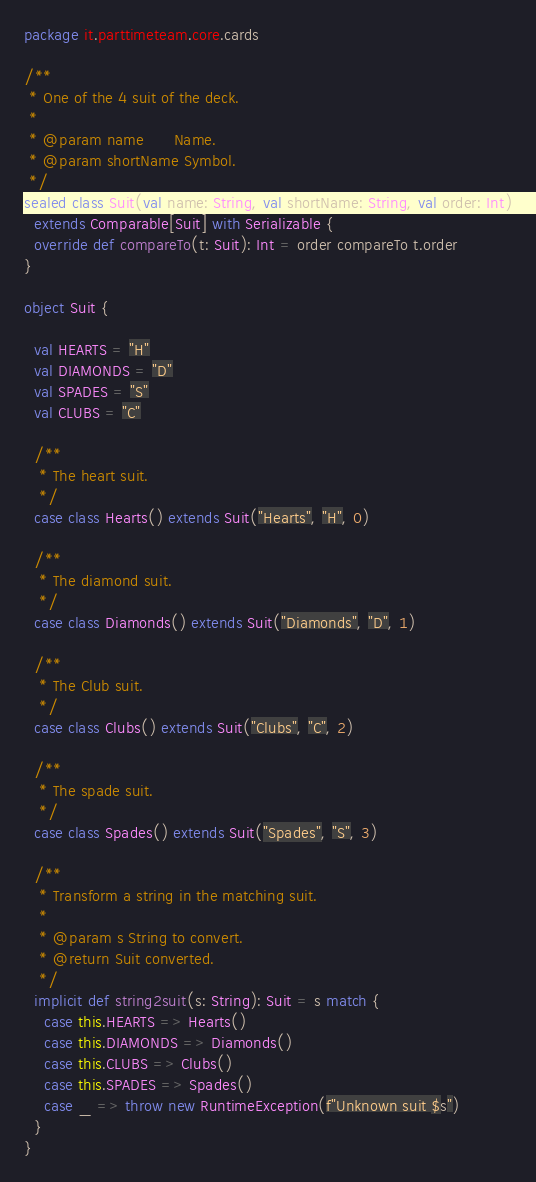<code> <loc_0><loc_0><loc_500><loc_500><_Scala_>package it.parttimeteam.core.cards

/**
 * One of the 4 suit of the deck.
 *
 * @param name      Name.
 * @param shortName Symbol.
 */
sealed class Suit(val name: String, val shortName: String, val order: Int)
  extends Comparable[Suit] with Serializable {
  override def compareTo(t: Suit): Int = order compareTo t.order
}

object Suit {

  val HEARTS = "H"
  val DIAMONDS = "D"
  val SPADES = "S"
  val CLUBS = "C"

  /**
   * The heart suit.
   */
  case class Hearts() extends Suit("Hearts", "H", 0)

  /**
   * The diamond suit.
   */
  case class Diamonds() extends Suit("Diamonds", "D", 1)

  /**
   * The Club suit.
   */
  case class Clubs() extends Suit("Clubs", "C", 2)

  /**
   * The spade suit.
   */
  case class Spades() extends Suit("Spades", "S", 3)

  /**
   * Transform a string in the matching suit.
   *
   * @param s String to convert.
   * @return Suit converted.
   */
  implicit def string2suit(s: String): Suit = s match {
    case this.HEARTS => Hearts()
    case this.DIAMONDS => Diamonds()
    case this.CLUBS => Clubs()
    case this.SPADES => Spades()
    case _ => throw new RuntimeException(f"Unknown suit $s")
  }
}</code> 